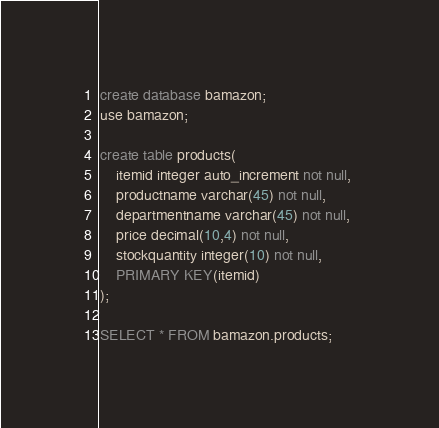Convert code to text. <code><loc_0><loc_0><loc_500><loc_500><_SQL_>create database bamazon;
use bamazon;

create table products(
    itemid integer auto_increment not null, 
    productname varchar(45) not null, 
    departmentname varchar(45) not null, 
    price decimal(10,4) not null,
    stockquantity integer(10) not null,
    PRIMARY KEY(itemid)
);

SELECT * FROM bamazon.products;
</code> 